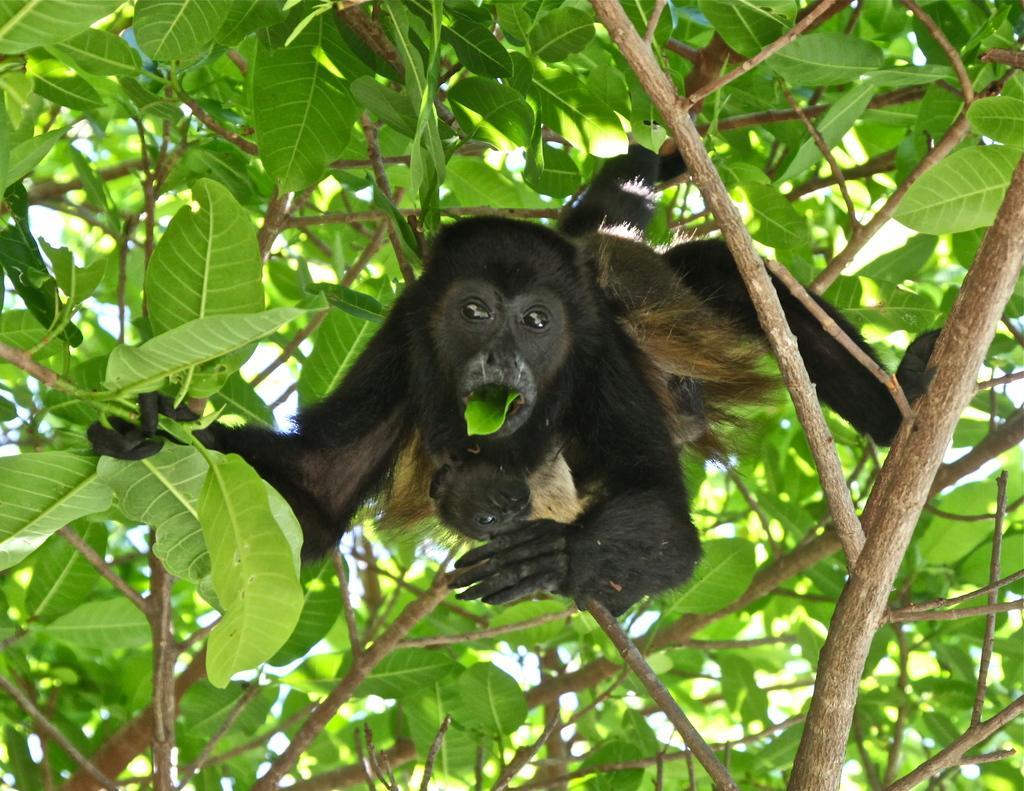How would you summarize this image in a sentence or two? In this image, we can see a chimpanzee on the tree stems and eating leaf. Here we can see leaves and stems. 